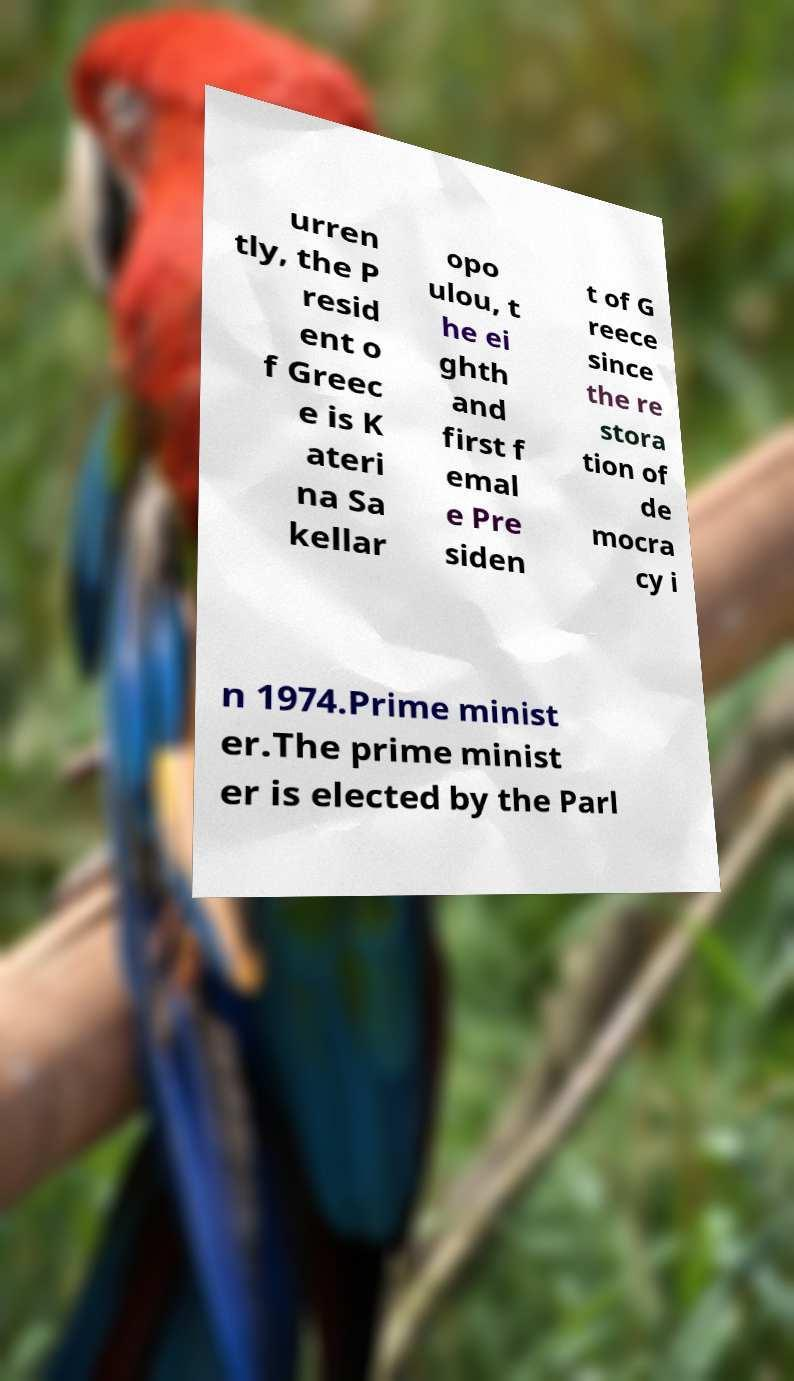Please read and relay the text visible in this image. What does it say? urren tly, the P resid ent o f Greec e is K ateri na Sa kellar opo ulou, t he ei ghth and first f emal e Pre siden t of G reece since the re stora tion of de mocra cy i n 1974.Prime minist er.The prime minist er is elected by the Parl 